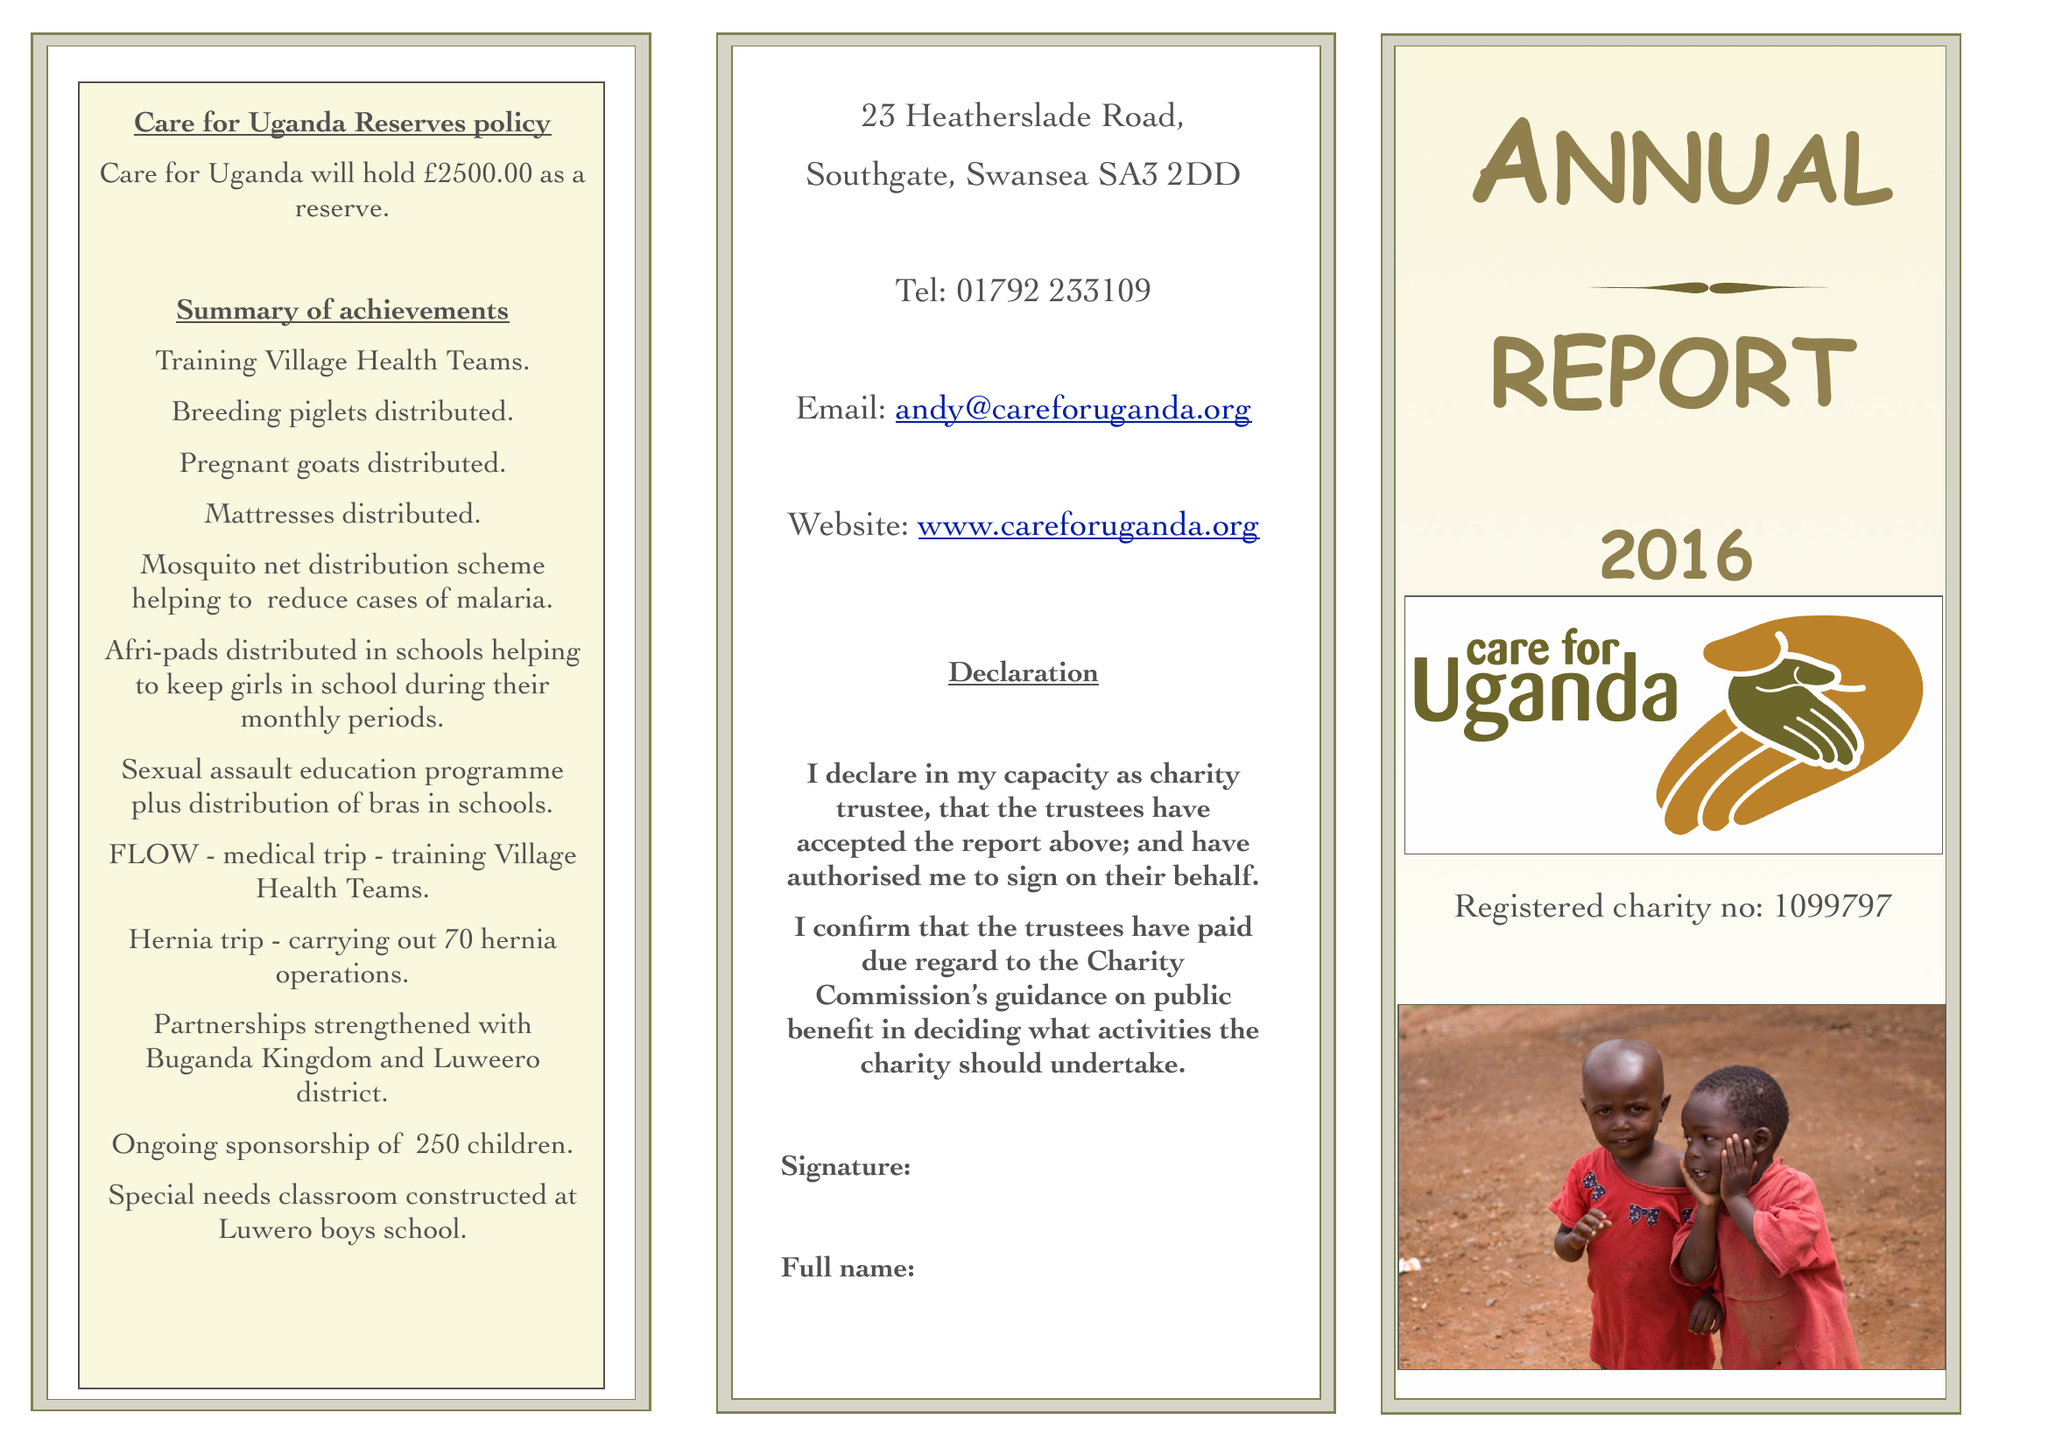What is the value for the spending_annually_in_british_pounds?
Answer the question using a single word or phrase. 111738.00 